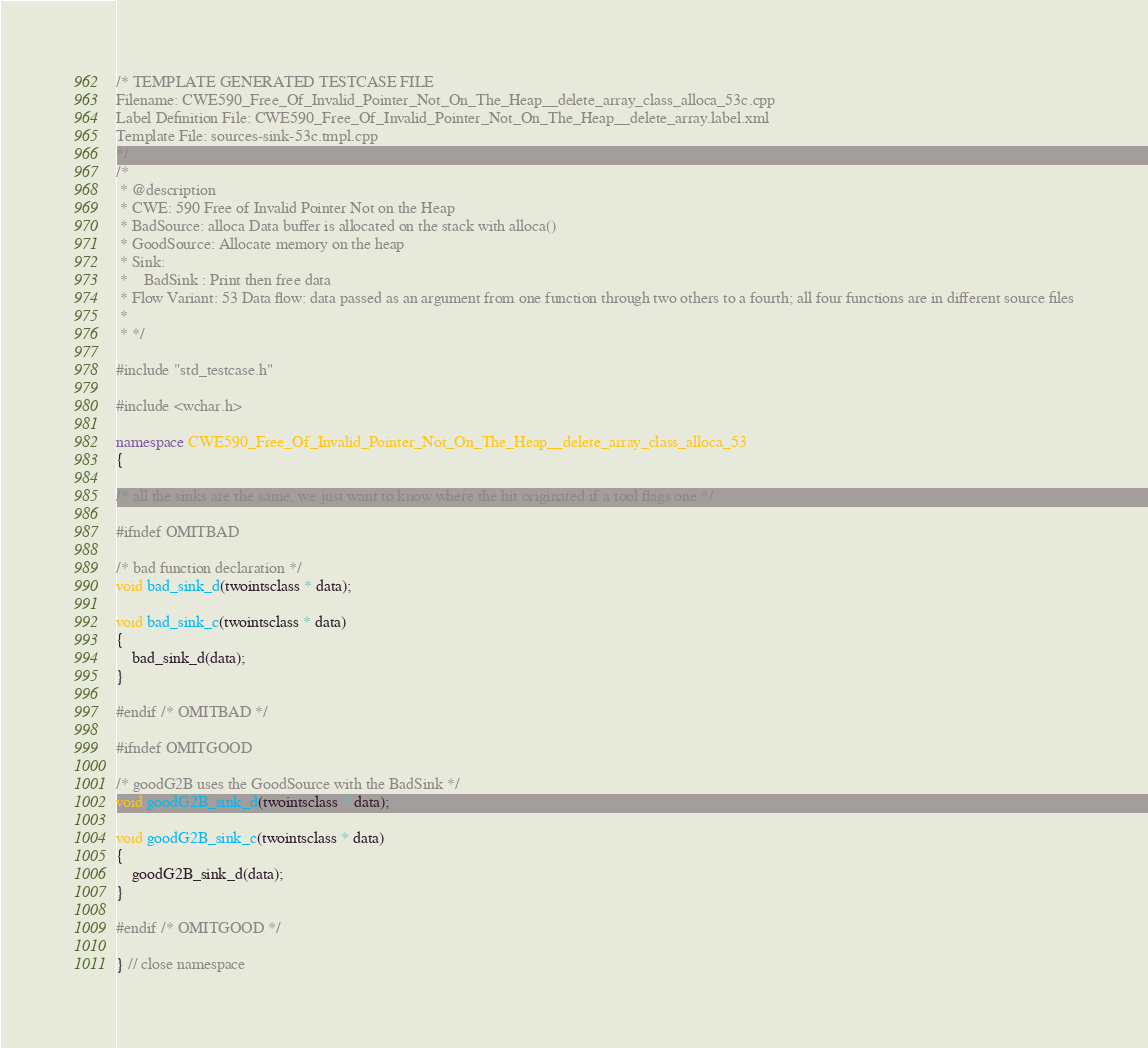Convert code to text. <code><loc_0><loc_0><loc_500><loc_500><_C++_>/* TEMPLATE GENERATED TESTCASE FILE
Filename: CWE590_Free_Of_Invalid_Pointer_Not_On_The_Heap__delete_array_class_alloca_53c.cpp
Label Definition File: CWE590_Free_Of_Invalid_Pointer_Not_On_The_Heap__delete_array.label.xml
Template File: sources-sink-53c.tmpl.cpp
*/
/*
 * @description
 * CWE: 590 Free of Invalid Pointer Not on the Heap
 * BadSource: alloca Data buffer is allocated on the stack with alloca()
 * GoodSource: Allocate memory on the heap
 * Sink:
 *    BadSink : Print then free data
 * Flow Variant: 53 Data flow: data passed as an argument from one function through two others to a fourth; all four functions are in different source files
 *
 * */

#include "std_testcase.h"

#include <wchar.h>

namespace CWE590_Free_Of_Invalid_Pointer_Not_On_The_Heap__delete_array_class_alloca_53
{

/* all the sinks are the same, we just want to know where the hit originated if a tool flags one */

#ifndef OMITBAD

/* bad function declaration */
void bad_sink_d(twointsclass * data);

void bad_sink_c(twointsclass * data)
{
    bad_sink_d(data);
}

#endif /* OMITBAD */

#ifndef OMITGOOD

/* goodG2B uses the GoodSource with the BadSink */
void goodG2B_sink_d(twointsclass * data);

void goodG2B_sink_c(twointsclass * data)
{
    goodG2B_sink_d(data);
}

#endif /* OMITGOOD */

} // close namespace
</code> 